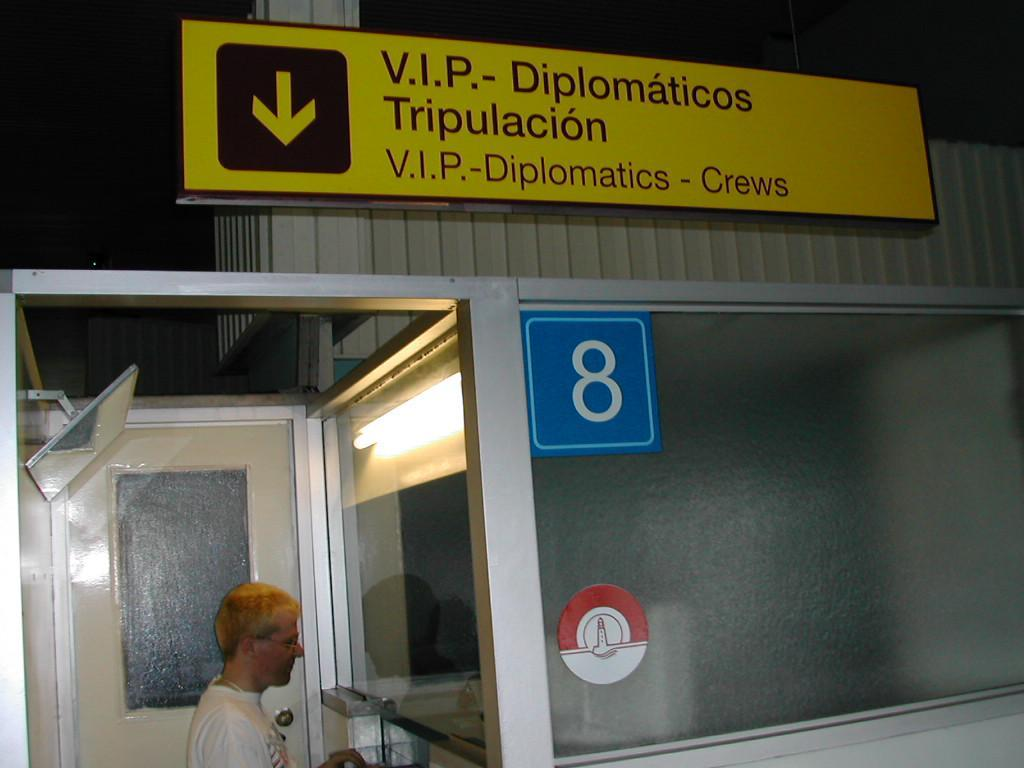What is on the yellow board in the image? There is writing on the yellow board in the image. What is the man near in the image? The man is standing near a mirror in the image. What can be seen in the background of the image? There is a door visible in the image. What type of liquid is being poured from the man's hand in the image? There is no liquid being poured in the image; the man is standing near a mirror. How large is the mirror in the image? The size of the mirror is not mentioned in the provided facts, so it cannot be determined from the image. 